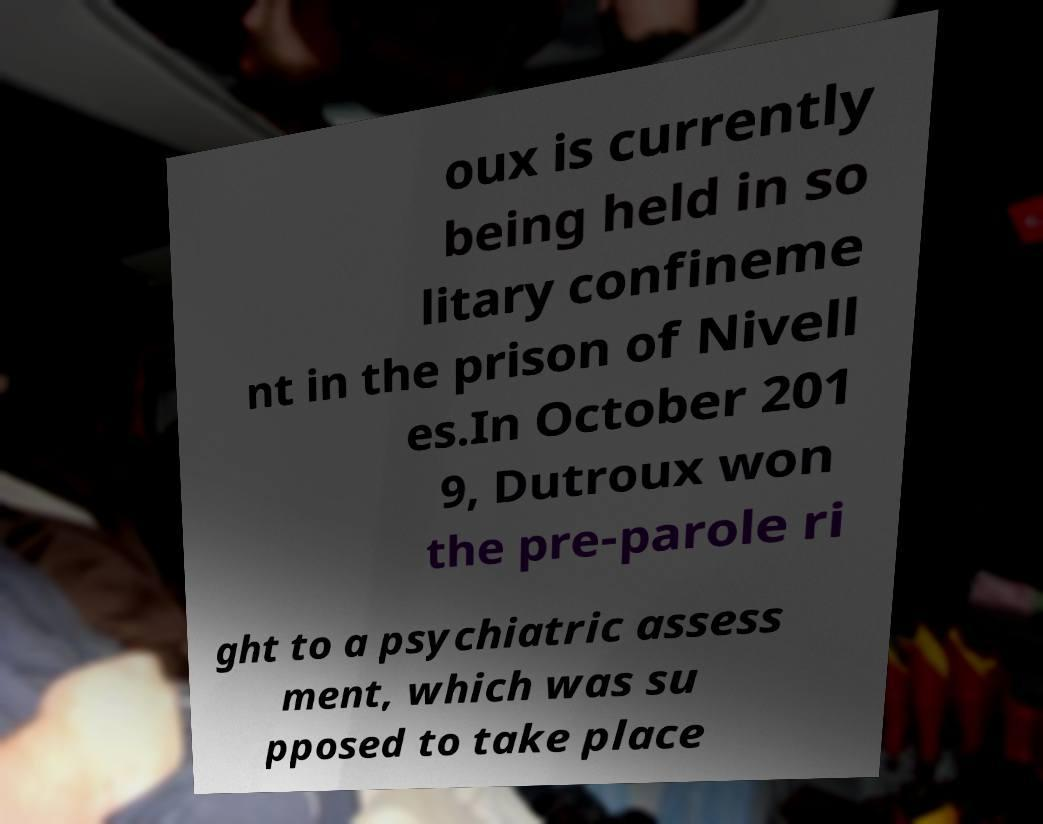Can you read and provide the text displayed in the image?This photo seems to have some interesting text. Can you extract and type it out for me? oux is currently being held in so litary confineme nt in the prison of Nivell es.In October 201 9, Dutroux won the pre-parole ri ght to a psychiatric assess ment, which was su pposed to take place 